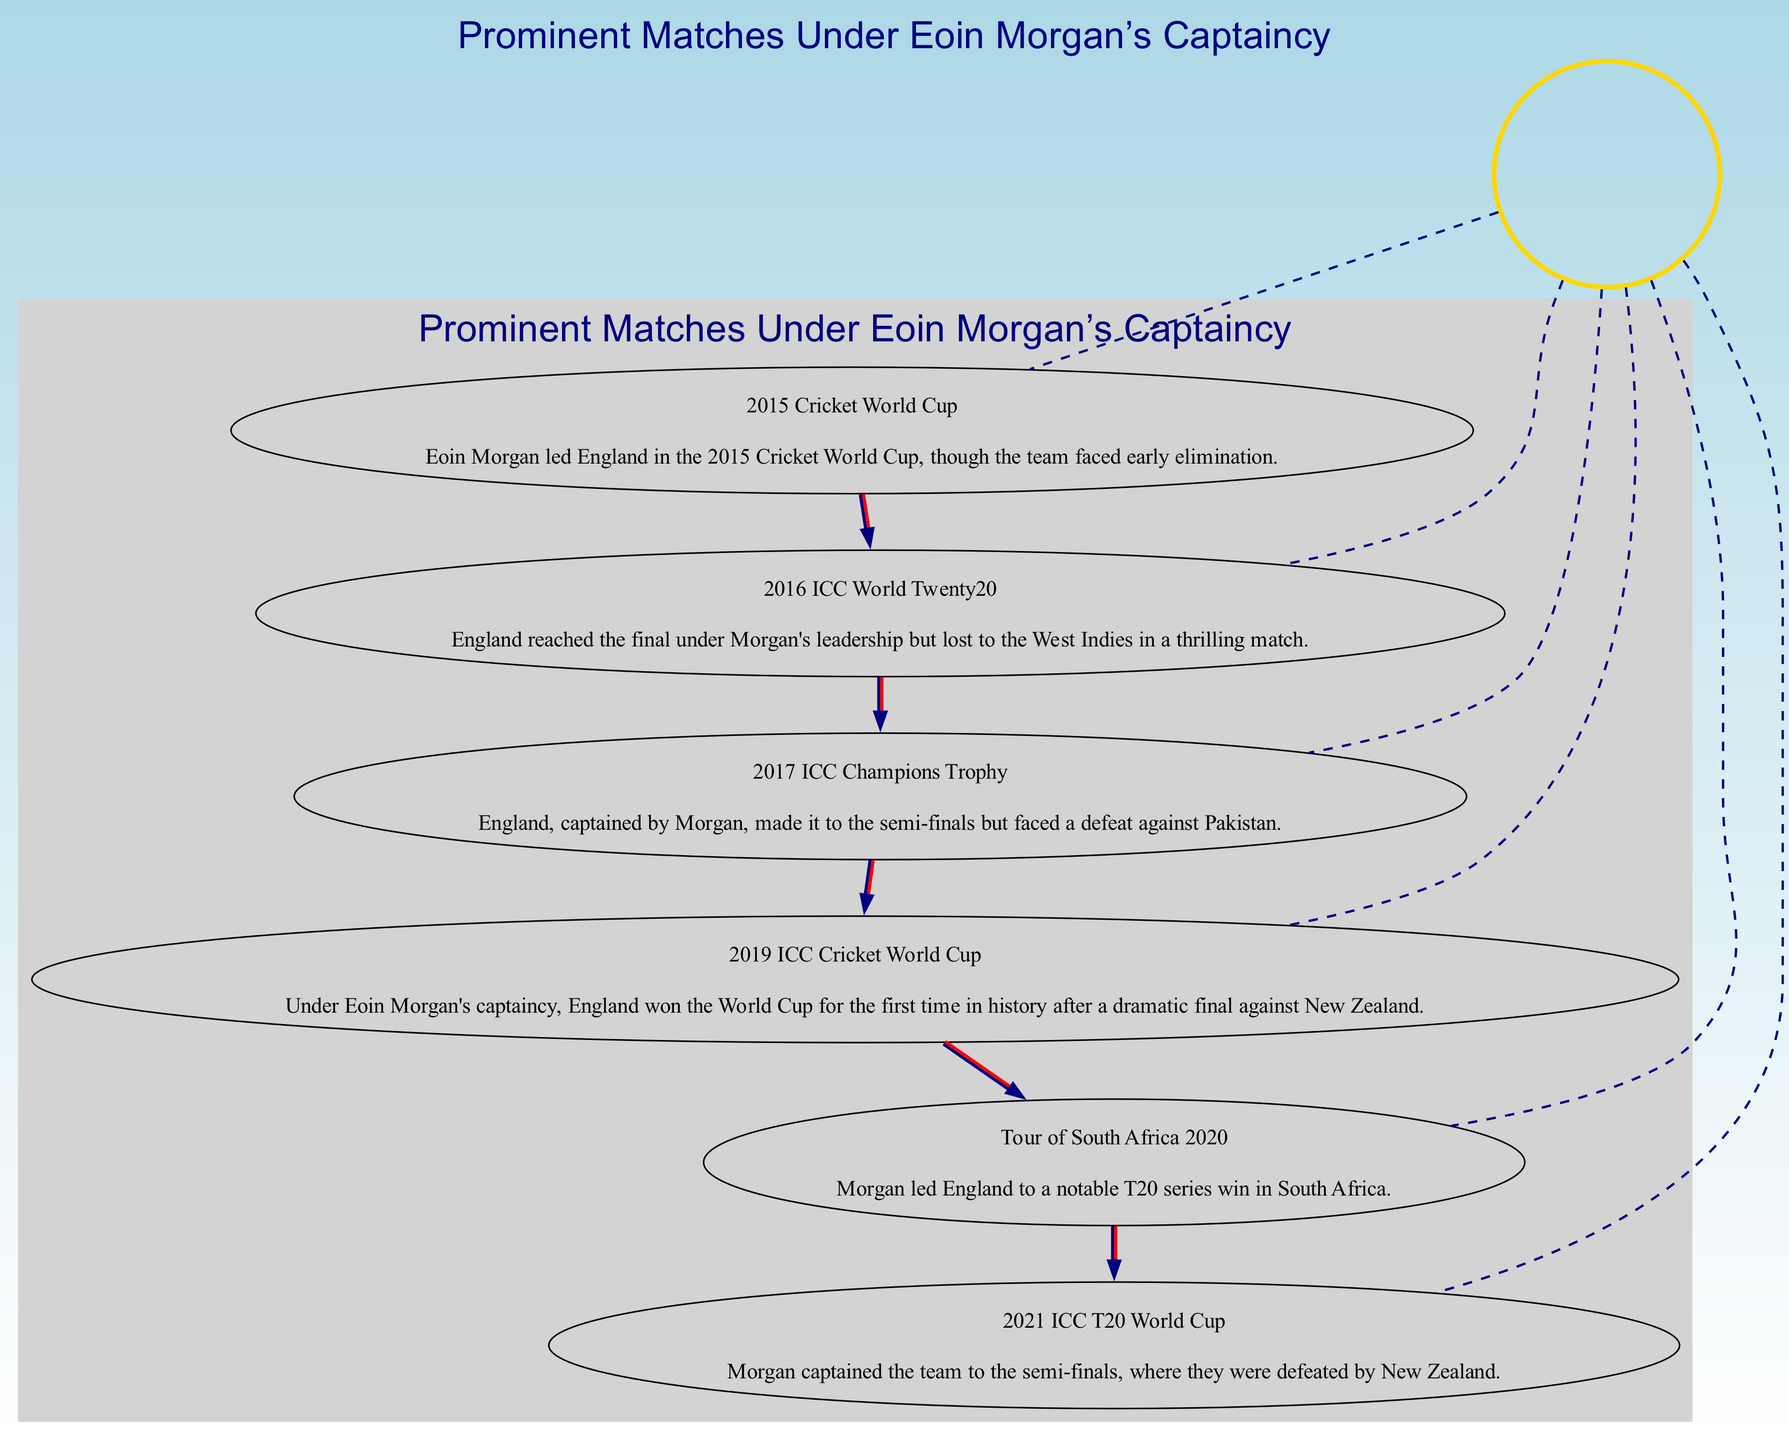What significant match did England win under Eoin Morgan's captaincy? The diagram indicates that England won the 2019 ICC Cricket World Cup under Eoin Morgan's captaincy, as it is highlighted as a prominent match and specifically mentions the victory.
Answer: 2019 ICC Cricket World Cup How many matches are displayed in the diagram? By counting the nodes in the diagram, it is evident that there are six distinct matches listed under Eoin Morgan's captaincy.
Answer: 6 Which match did England reach but lose in the finals under Morgan? The diagram points out that England reached the final in the 2016 ICC World Twenty20 but lost to the West Indies. This is explicitly described in the nodes.
Answer: 2016 ICC World Twenty20 What was the outcome of the 2017 ICC Champions Trophy under Morgan's leadership? The diagram states that during the 2017 ICC Champions Trophy, England, captained by Morgan, made it to the semi-finals but faced defeat against Pakistan. Thus, the outcome was a loss.
Answer: Defeat against Pakistan In which year did England have a T20 series win in South Africa led by Morgan? The diagram specifies that in the year 2020, during the Tour of South Africa, Morgan led England to a notable T20 series win.
Answer: 2020 Which team defeated England in the semi-finals of the 2021 ICC T20 World Cup? According to the diagram, England was defeated by New Zealand in the semi-finals of the 2021 ICC T20 World Cup, as it is clearly stated in the description of that match.
Answer: New Zealand Which match shows Eoin Morgan's most successful captaincy moment? The diagram highlights that the most successful moment was the 2019 ICC Cricket World Cup where England won for the first time, making it particularly significant among all matches.
Answer: 2019 ICC Cricket World Cup Which match was marked as a thrilling encounter although it ended in a loss? The description of the 2016 ICC World Twenty20 match in the diagram indicates it was a thrilling match despite England losing to the West Indies.
Answer: 2016 ICC World Twenty20 In which match did England make it to the semi-finals but ultimately did not advance? Based on the diagram, the 2017 ICC Champions Trophy shows that England reached the semi-finals and did not advance, ensuring it is marked as an important match.
Answer: 2017 ICC Champions Trophy 